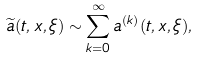Convert formula to latex. <formula><loc_0><loc_0><loc_500><loc_500>\widetilde { a } ( t , x , \xi ) \sim \sum _ { k = 0 } ^ { \infty } a ^ { ( k ) } ( t , x , \xi ) ,</formula> 